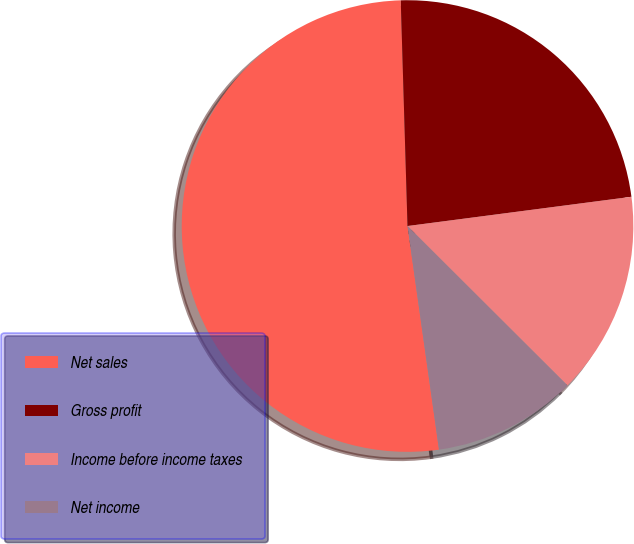Convert chart to OTSL. <chart><loc_0><loc_0><loc_500><loc_500><pie_chart><fcel>Net sales<fcel>Gross profit<fcel>Income before income taxes<fcel>Net income<nl><fcel>51.75%<fcel>23.41%<fcel>14.54%<fcel>10.3%<nl></chart> 